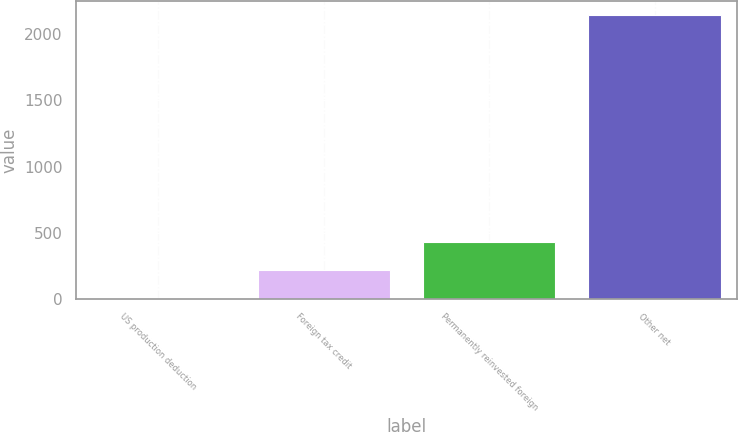Convert chart. <chart><loc_0><loc_0><loc_500><loc_500><bar_chart><fcel>US production deduction<fcel>Foreign tax credit<fcel>Permanently reinvested foreign<fcel>Other net<nl><fcel>1.48<fcel>215.83<fcel>430.18<fcel>2145<nl></chart> 